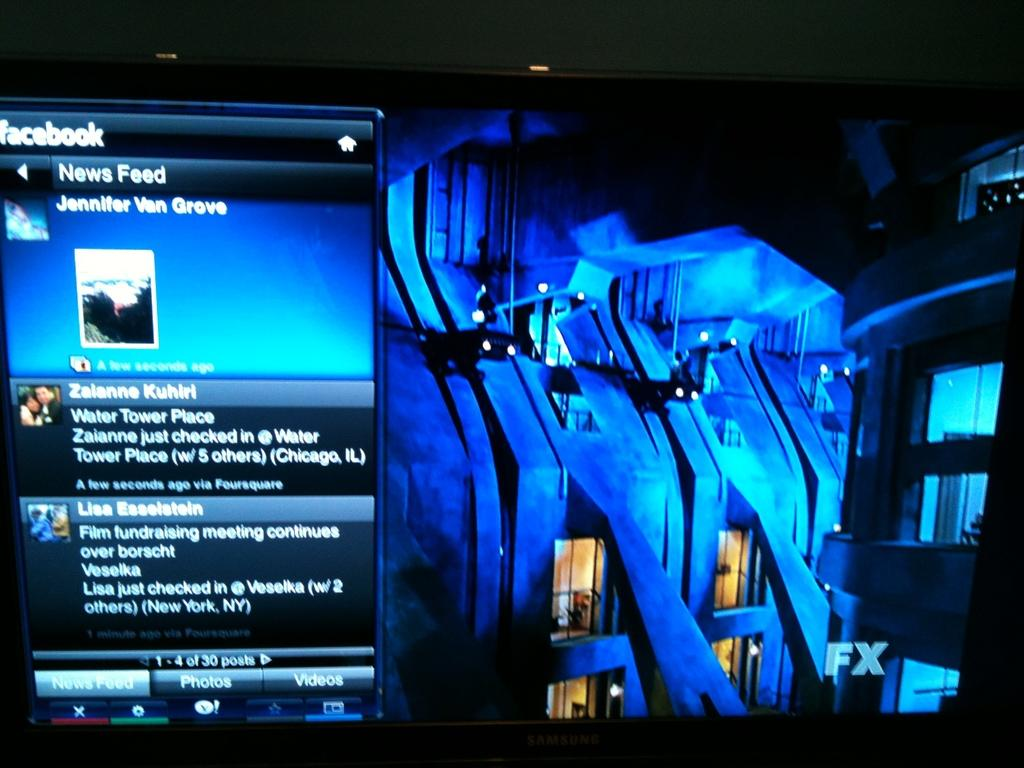<image>
Provide a brief description of the given image. A large screen with a facebook news feed on the left side. 